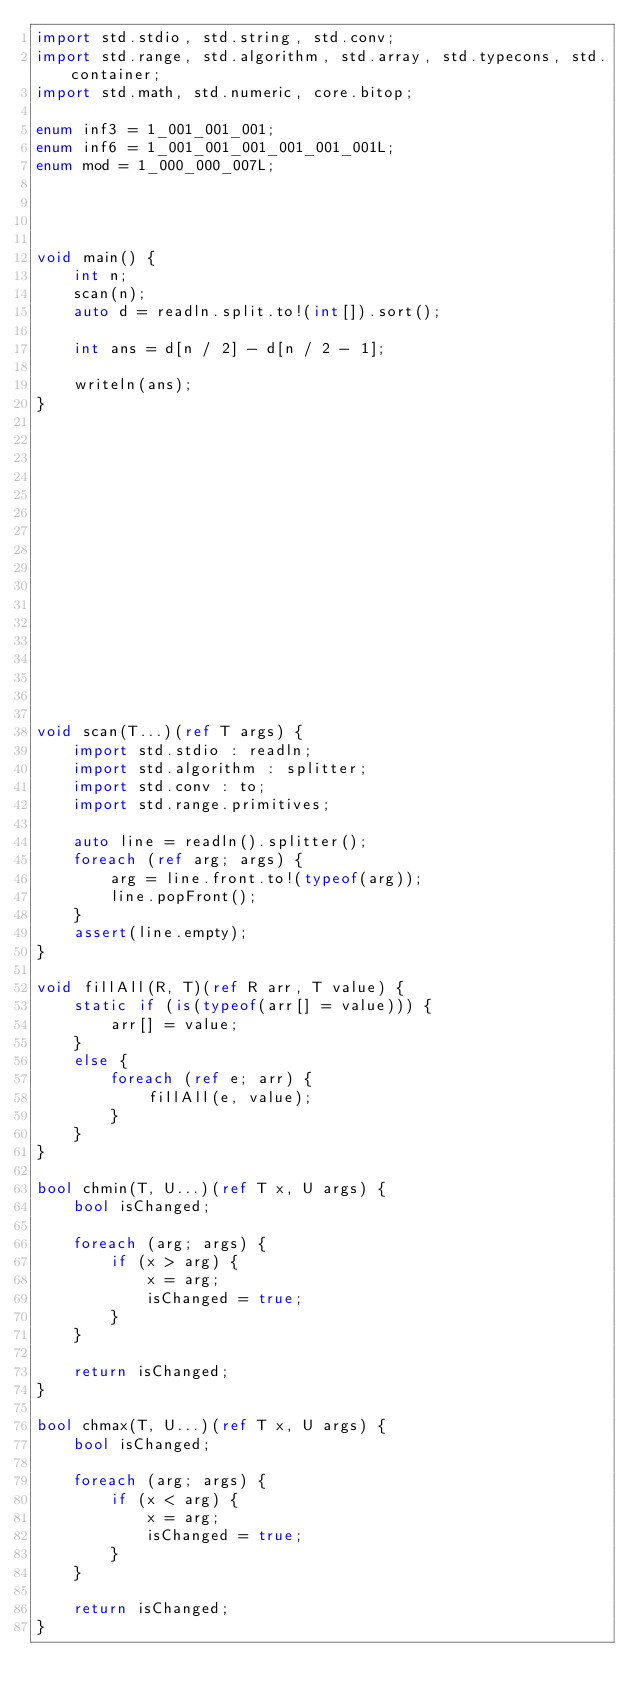Convert code to text. <code><loc_0><loc_0><loc_500><loc_500><_D_>import std.stdio, std.string, std.conv;
import std.range, std.algorithm, std.array, std.typecons, std.container;
import std.math, std.numeric, core.bitop;

enum inf3 = 1_001_001_001;
enum inf6 = 1_001_001_001_001_001_001L;
enum mod = 1_000_000_007L;




void main() {
    int n;
    scan(n);
    auto d = readln.split.to!(int[]).sort();

    int ans = d[n / 2] - d[n / 2 - 1];

    writeln(ans);
}

















void scan(T...)(ref T args) {
    import std.stdio : readln;
    import std.algorithm : splitter;
    import std.conv : to;
    import std.range.primitives;

    auto line = readln().splitter();
    foreach (ref arg; args) {
        arg = line.front.to!(typeof(arg));
        line.popFront();
    }
    assert(line.empty);
}

void fillAll(R, T)(ref R arr, T value) {
    static if (is(typeof(arr[] = value))) {
        arr[] = value;
    }
    else {
        foreach (ref e; arr) {
            fillAll(e, value);
        }
    }
}

bool chmin(T, U...)(ref T x, U args) {
    bool isChanged;

    foreach (arg; args) {
        if (x > arg) {
            x = arg;
            isChanged = true;
        }
    }

    return isChanged;
}

bool chmax(T, U...)(ref T x, U args) {
    bool isChanged;

    foreach (arg; args) {
        if (x < arg) {
            x = arg;
            isChanged = true;
        }
    }

    return isChanged;
}
</code> 